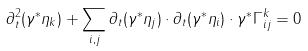<formula> <loc_0><loc_0><loc_500><loc_500>\partial _ { t } ^ { 2 } ( \gamma ^ { * } \eta _ { k } ) + \sum _ { i , j } \partial _ { t } ( \gamma ^ { * } \eta _ { j } ) \cdot \partial _ { t } ( \gamma ^ { * } \eta _ { i } ) \cdot \gamma ^ { * } \Gamma _ { i j } ^ { k } = 0</formula> 